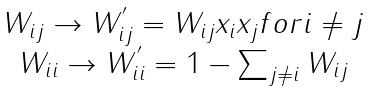<formula> <loc_0><loc_0><loc_500><loc_500>\begin{array} { c } W _ { i j } \rightarrow W _ { i j } ^ { ^ { \prime } } = W _ { i j } x _ { i } x _ { j } f o r i \neq j \\ W _ { i i } \rightarrow W _ { i i } ^ { ^ { \prime } } = 1 - \sum _ { j \neq i } W _ { i j } \end{array}</formula> 